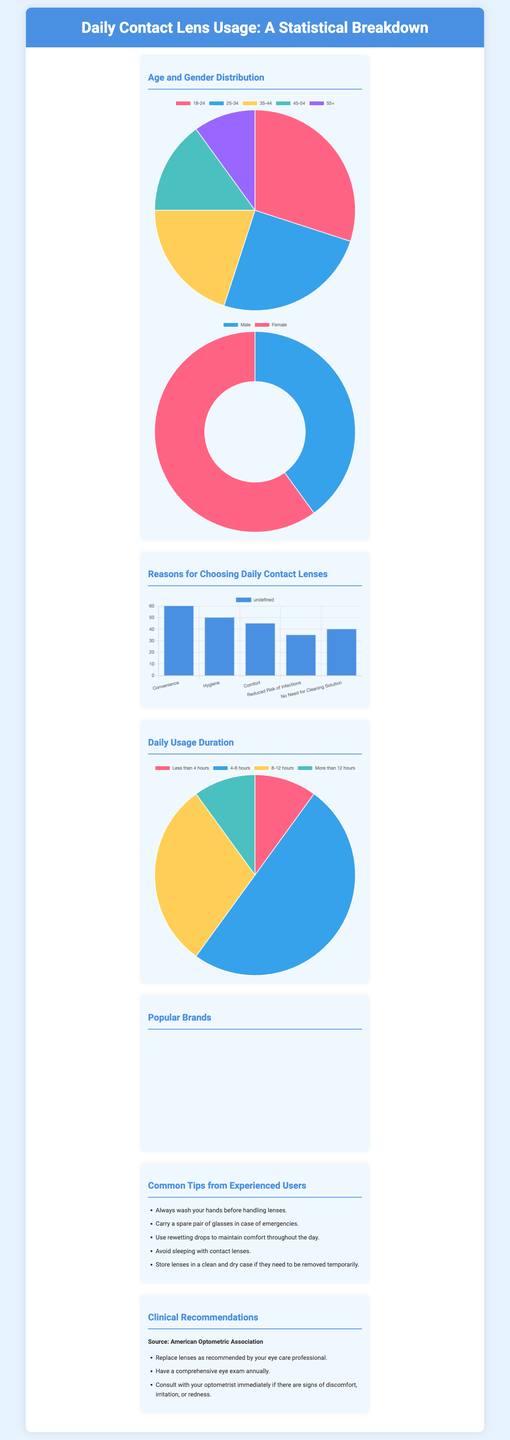what is the most popular reason for choosing daily contact lenses? The document states that the most popular reason for choosing daily contact lenses is convenience, with a value of 60.
Answer: Convenience what percentage of users are female? According to the gender distribution chart, 60% of contact lens users are female.
Answer: 60% which age group has the highest usage percentage? The age group with the highest usage percentage is 18-24, accounting for 30% of users.
Answer: 18-24 how many users wear contact lenses for 4-8 hours daily? The pie chart indicates that 50% of users wear contact lenses for 4-8 hours daily.
Answer: 50% what is the brand with the highest usage among users? The brand with the highest usage is Acuvue Moist, which accounts for 25% of users.
Answer: Acuvue Moist what clinical recommendation is emphasized for users? The document emphasizes replacing lenses as recommended by your eye care professional.
Answer: Replace lenses what is the total number of reasons listed for choosing daily contact lenses? There are five reasons listed for choosing daily contact lenses in the infographic.
Answer: Five what type of chart is used to display age distribution? A pie chart is used to display the age distribution of contact lens users.
Answer: Pie chart how many common tips are provided for experienced users? The document provides five common tips from experienced users.
Answer: Five 